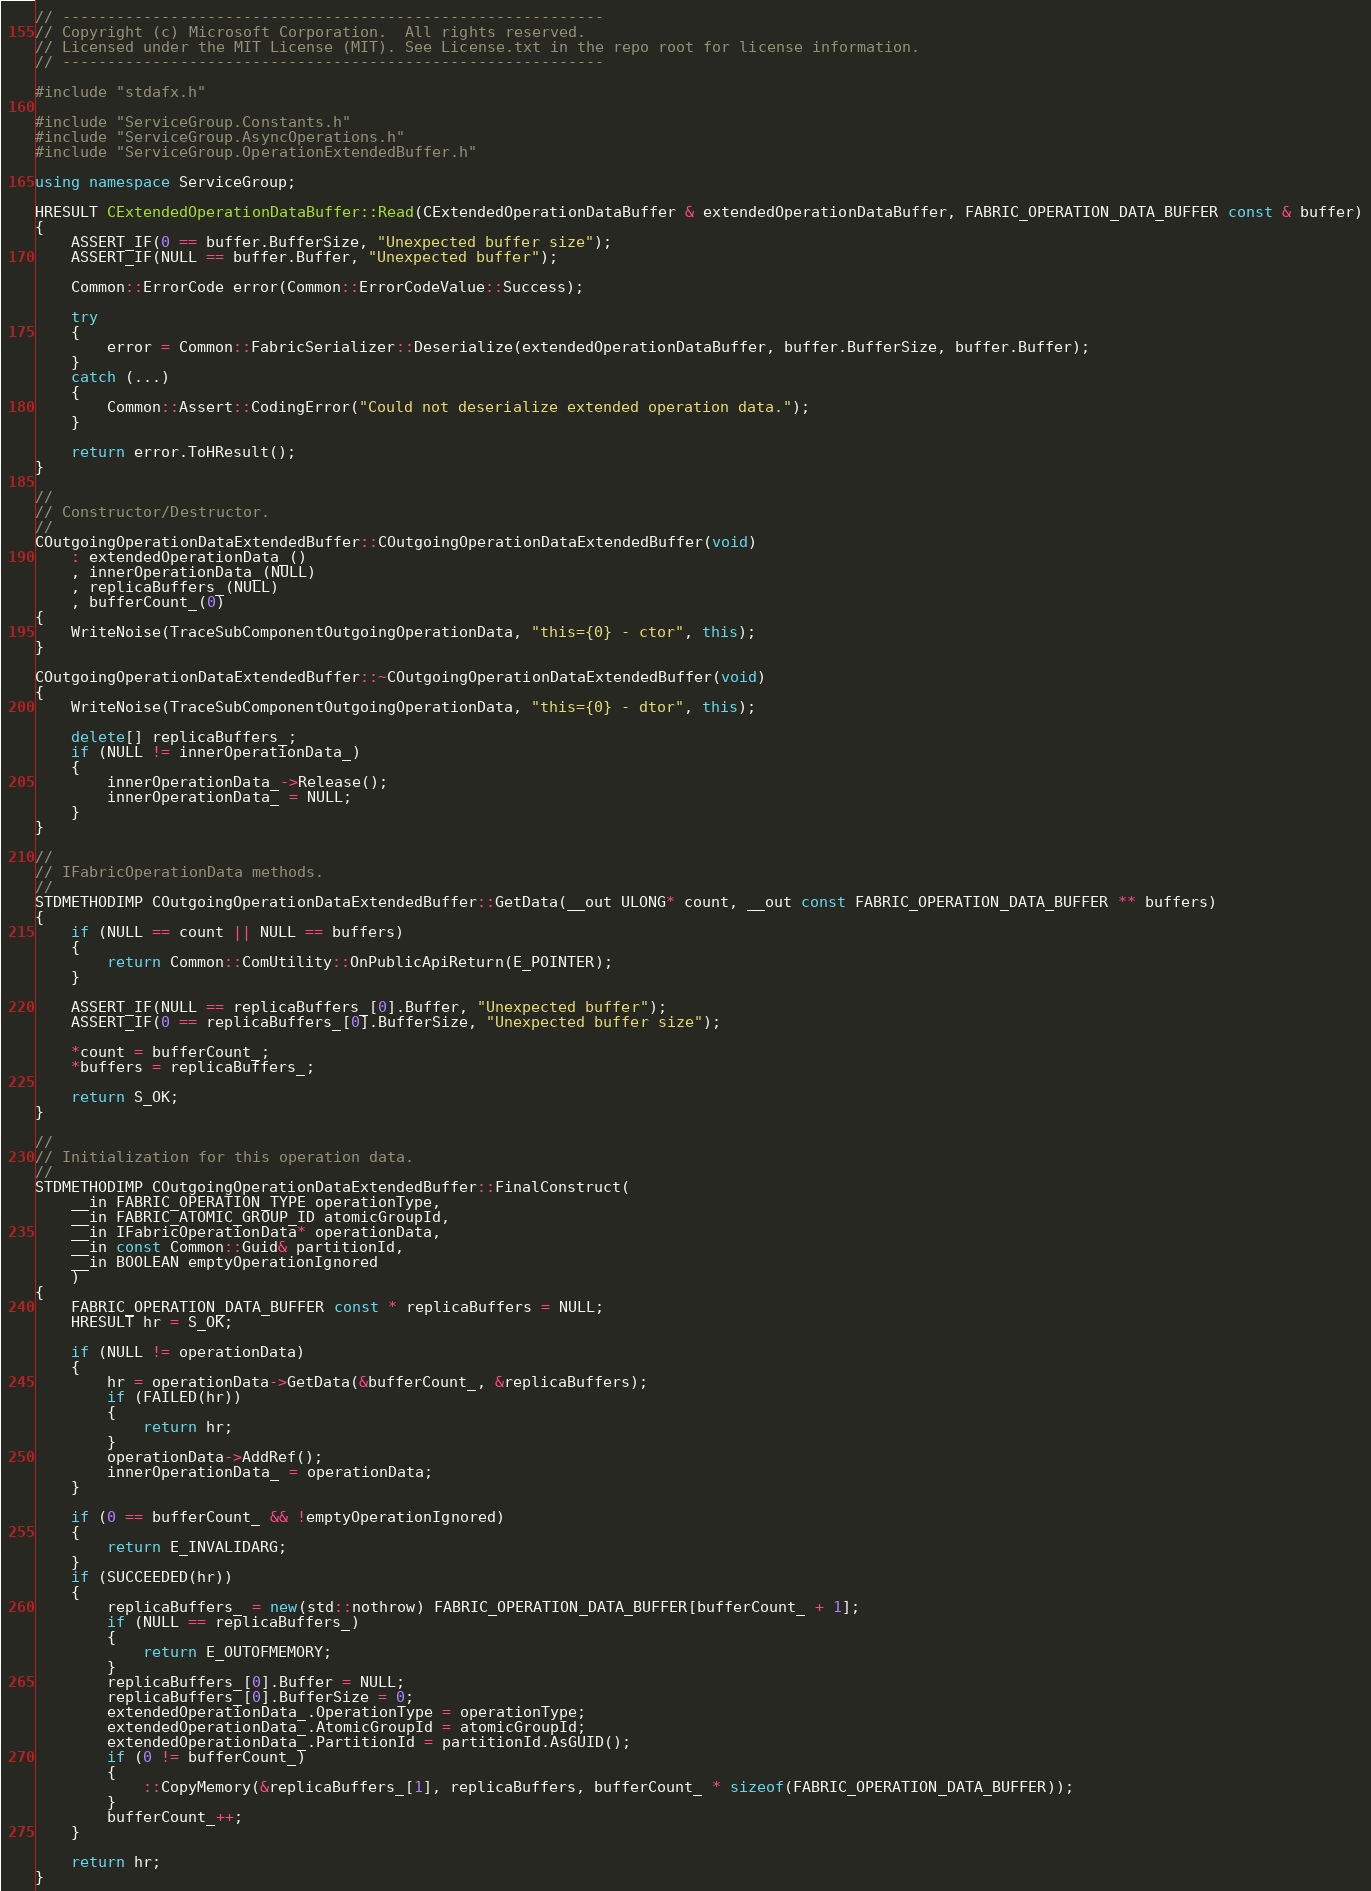<code> <loc_0><loc_0><loc_500><loc_500><_C++_>// ------------------------------------------------------------
// Copyright (c) Microsoft Corporation.  All rights reserved.
// Licensed under the MIT License (MIT). See License.txt in the repo root for license information.
// ------------------------------------------------------------

#include "stdafx.h"

#include "ServiceGroup.Constants.h"
#include "ServiceGroup.AsyncOperations.h"
#include "ServiceGroup.OperationExtendedBuffer.h"

using namespace ServiceGroup;

HRESULT CExtendedOperationDataBuffer::Read(CExtendedOperationDataBuffer & extendedOperationDataBuffer, FABRIC_OPERATION_DATA_BUFFER const & buffer)
{
    ASSERT_IF(0 == buffer.BufferSize, "Unexpected buffer size");
    ASSERT_IF(NULL == buffer.Buffer, "Unexpected buffer");

    Common::ErrorCode error(Common::ErrorCodeValue::Success);

    try
    {
        error = Common::FabricSerializer::Deserialize(extendedOperationDataBuffer, buffer.BufferSize, buffer.Buffer);
    }
    catch (...)
    {
        Common::Assert::CodingError("Could not deserialize extended operation data.");
    }

    return error.ToHResult();
}

//
// Constructor/Destructor.
//
COutgoingOperationDataExtendedBuffer::COutgoingOperationDataExtendedBuffer(void)
    : extendedOperationData_()
    , innerOperationData_(NULL)
    , replicaBuffers_(NULL)
    , bufferCount_(0)
{
    WriteNoise(TraceSubComponentOutgoingOperationData, "this={0} - ctor", this);
}

COutgoingOperationDataExtendedBuffer::~COutgoingOperationDataExtendedBuffer(void)
{
    WriteNoise(TraceSubComponentOutgoingOperationData, "this={0} - dtor", this);

    delete[] replicaBuffers_;
    if (NULL != innerOperationData_)
    {
        innerOperationData_->Release();
        innerOperationData_ = NULL;
    }
}

//
// IFabricOperationData methods.
//
STDMETHODIMP COutgoingOperationDataExtendedBuffer::GetData(__out ULONG* count, __out const FABRIC_OPERATION_DATA_BUFFER ** buffers)
{
    if (NULL == count || NULL == buffers)
    {
        return Common::ComUtility::OnPublicApiReturn(E_POINTER);
    }

    ASSERT_IF(NULL == replicaBuffers_[0].Buffer, "Unexpected buffer");
    ASSERT_IF(0 == replicaBuffers_[0].BufferSize, "Unexpected buffer size");
    
    *count = bufferCount_;
    *buffers = replicaBuffers_;

    return S_OK;
}

//
// Initialization for this operation data.
//
STDMETHODIMP COutgoingOperationDataExtendedBuffer::FinalConstruct(
    __in FABRIC_OPERATION_TYPE operationType, 
    __in FABRIC_ATOMIC_GROUP_ID atomicGroupId, 
    __in IFabricOperationData* operationData,
    __in const Common::Guid& partitionId,
    __in BOOLEAN emptyOperationIgnored
    )
{
    FABRIC_OPERATION_DATA_BUFFER const * replicaBuffers = NULL;
    HRESULT hr = S_OK;

    if (NULL != operationData)
    {
        hr = operationData->GetData(&bufferCount_, &replicaBuffers);
        if (FAILED(hr))
        {
            return hr;
        }
        operationData->AddRef();
        innerOperationData_ = operationData;
    }

    if (0 == bufferCount_ && !emptyOperationIgnored)
    {
        return E_INVALIDARG;
    }
    if (SUCCEEDED(hr))
    {
        replicaBuffers_ = new(std::nothrow) FABRIC_OPERATION_DATA_BUFFER[bufferCount_ + 1];
        if (NULL == replicaBuffers_)
        {
            return E_OUTOFMEMORY;
        }
        replicaBuffers_[0].Buffer = NULL;
        replicaBuffers_[0].BufferSize = 0;
        extendedOperationData_.OperationType = operationType;
        extendedOperationData_.AtomicGroupId = atomicGroupId;
        extendedOperationData_.PartitionId = partitionId.AsGUID();
        if (0 != bufferCount_)
        {
            ::CopyMemory(&replicaBuffers_[1], replicaBuffers, bufferCount_ * sizeof(FABRIC_OPERATION_DATA_BUFFER));
        }
        bufferCount_++;
    }

    return hr;
}
</code> 